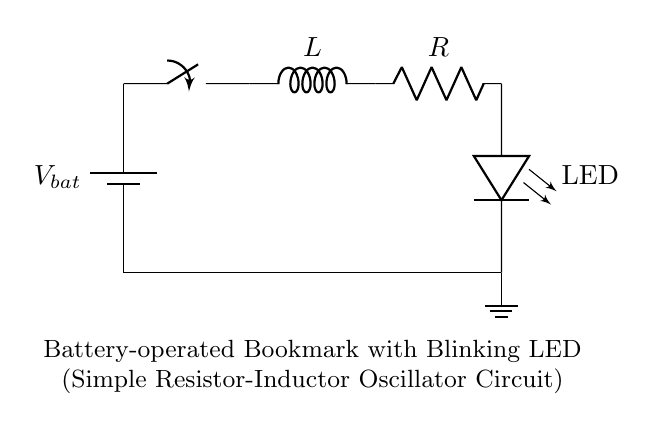What components are present in this circuit? The circuit consists of a battery, switch, inductor, resistor, and LED. These components are visually represented and identifiable in the diagram.
Answer: battery, switch, inductor, resistor, LED What is the function of the switch in this circuit? The switch controls the flow of current; when closed, it allows current to flow through the circuit, powering the LED, and when open, it interrupts the flow.
Answer: control current flow What type of circuit is this? This is a resistor-inductor oscillator circuit, as it includes a resistor and an inductor that work together to produce oscillations in the current through the combined inductance and resistance.
Answer: resistor-inductor oscillator What happens to the LED when the switch is closed? Closing the switch completes the circuit, allowing current to flow, which energizes the LED and causes it to blink due to the oscillation created by the resistor and inductor.
Answer: LED blinks How does the inductor affect the blinking of the LED? The inductor stores energy when current flows through it and then releases that energy back into the circuit, creating a delay which leads to the blinking effect. The oscillations in current result from this store and discharge cycle.
Answer: creates blinking effect What is the role of the resistor in this circuit? The resistor limits the amount of current flowing through the circuit, ensuring that the LED receives a safe amount of current and contributes to the timing of the oscillation.
Answer: limits current flow 